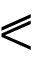Convert formula to latex. <formula><loc_0><loc_0><loc_500><loc_500>\ e q s l a n t l e s s</formula> 